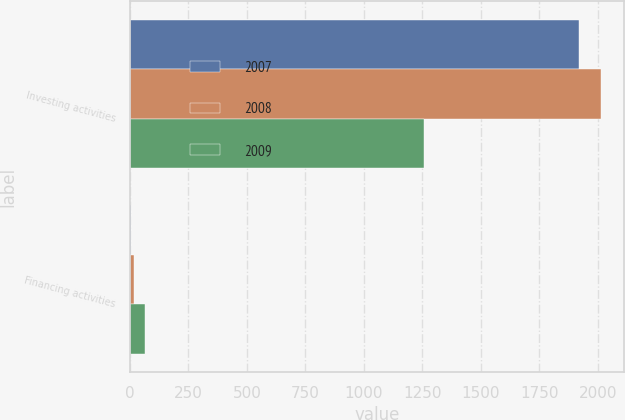Convert chart. <chart><loc_0><loc_0><loc_500><loc_500><stacked_bar_chart><ecel><fcel>Investing activities<fcel>Financing activities<nl><fcel>2007<fcel>1919<fcel>6<nl><fcel>2008<fcel>2012<fcel>16<nl><fcel>2009<fcel>1255<fcel>66<nl></chart> 